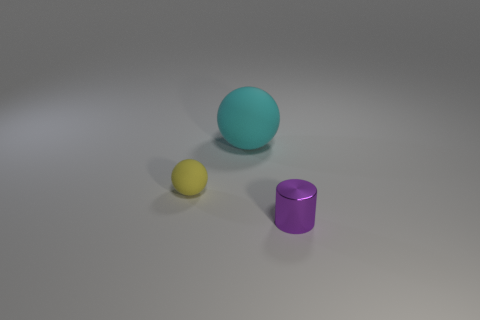What is the shape of the yellow thing that is the same size as the purple cylinder? The yellow object, which is the same size as the purple cylinder in the image, is a sphere. It's interesting to note how lights and shadows play on its surface, creating a realistic sense of depth and form. 